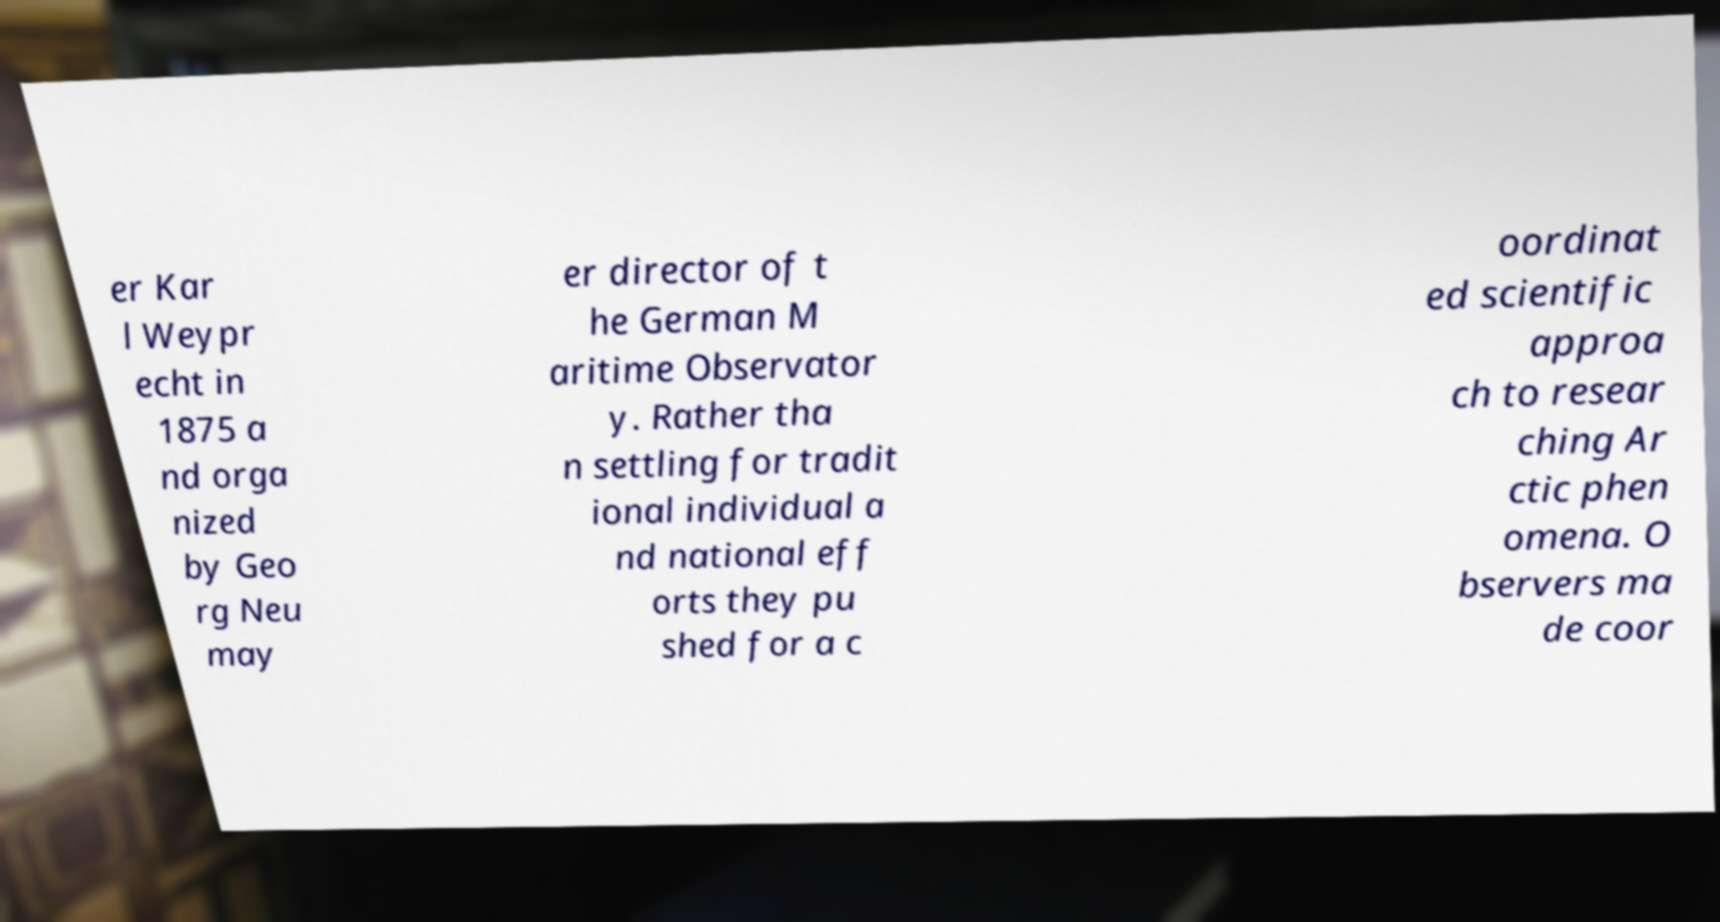Can you read and provide the text displayed in the image?This photo seems to have some interesting text. Can you extract and type it out for me? er Kar l Weypr echt in 1875 a nd orga nized by Geo rg Neu may er director of t he German M aritime Observator y. Rather tha n settling for tradit ional individual a nd national eff orts they pu shed for a c oordinat ed scientific approa ch to resear ching Ar ctic phen omena. O bservers ma de coor 